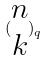Convert formula to latex. <formula><loc_0><loc_0><loc_500><loc_500>( \begin{matrix} n \\ k \end{matrix} ) _ { q }</formula> 